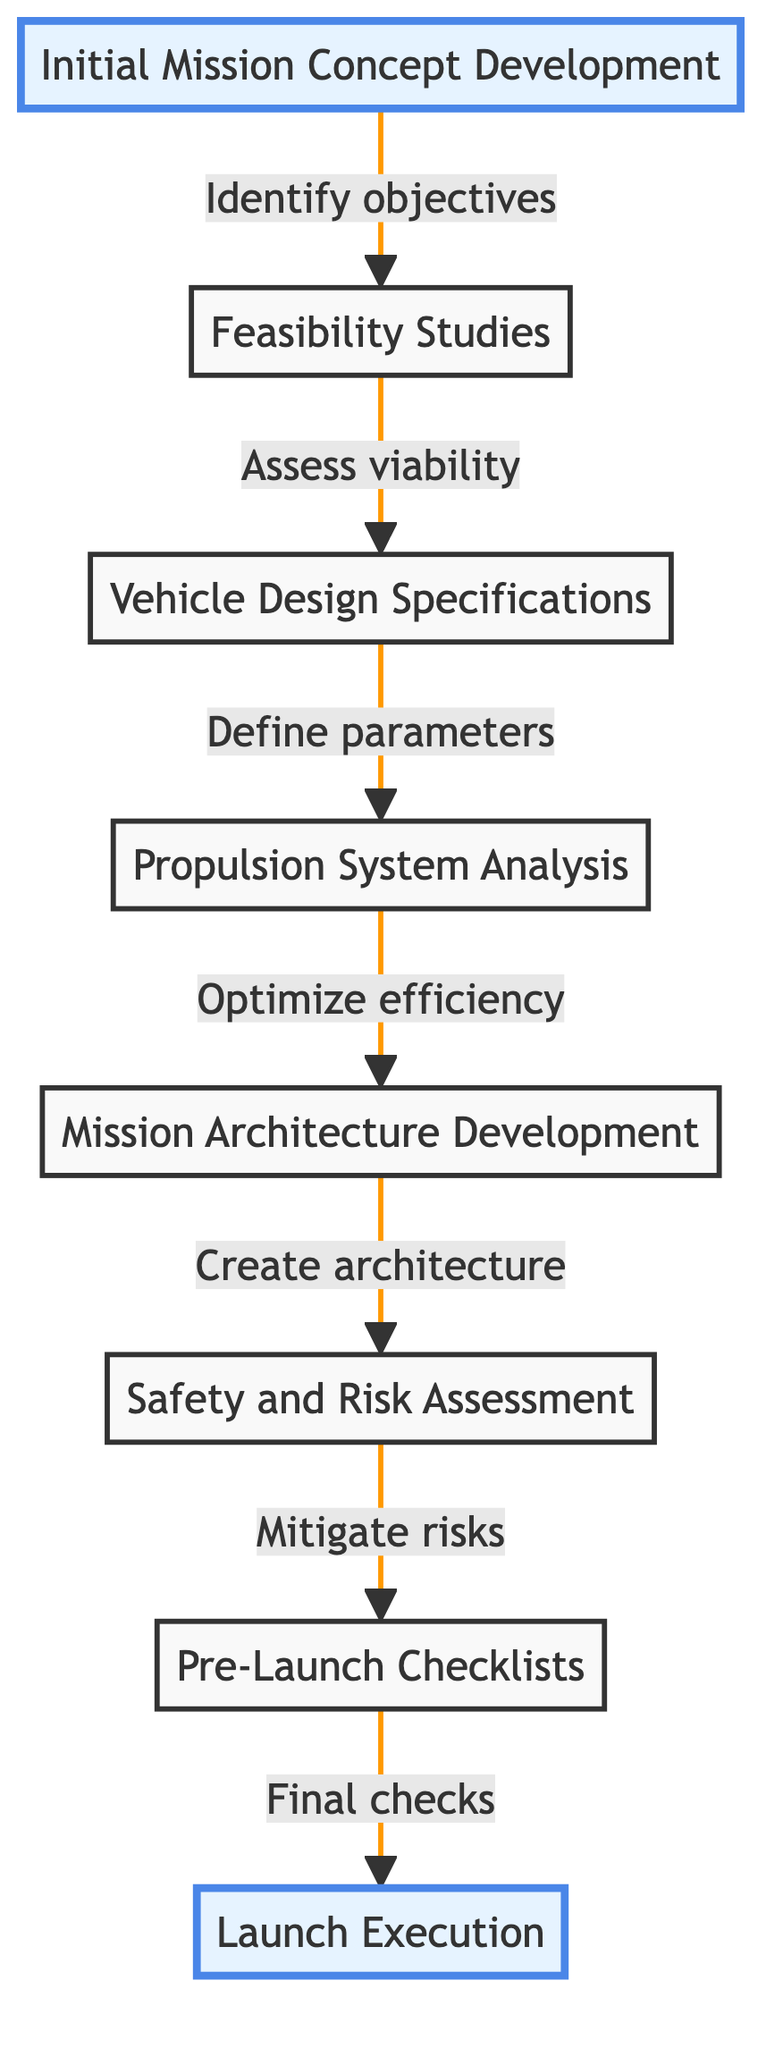What is the first step in the mission planning workflow? The first step shown in the diagram is "Initial Mission Concept Development," which identifies the mission objectives and payload requirements.
Answer: Initial Mission Concept Development How many steps are there in total in the flowchart? The diagram lists eight distinct steps that make up the mission planning workflow, from initial concept to launch execution.
Answer: 8 Which step directly follows the "Vehicle Design Specifications" step? According to the flowchart, the "Propulsion System Analysis" step directly follows "Vehicle Design Specifications," indicating an evaluation of propulsion options.
Answer: Propulsion System Analysis What is the relationship between "Safety and Risk Assessment" and "Pre-Launch Checklists"? "Safety and Risk Assessment" leads directly to "Pre-Launch Checklists," suggesting that assessing risks is a precursor to final systems checks before launch.
Answer: Pre-Launch Checklists Identify the step focused on optimizing fuel efficiency. The step dedicated to optimizing fuel efficiency is "Propulsion System Analysis," where various propulsion options are evaluated.
Answer: Propulsion System Analysis What actions are included in the "Launch Execution" phase? The "Launch Execution" phase involves carrying out the launch sequence and monitoring vehicle performance, marking the transition from preparation to action.
Answer: Launch Execution Which step requires both identifying hazards and mitigating risks? The "Safety and Risk Assessment" step involves both identifying potential hazards and implementing measures to mitigate those risks before moving forward to final checks.
Answer: Safety and Risk Assessment What is created during the "Mission Architecture Development"? This step focuses on creating a comprehensive mission architecture, which encompasses all aspects such as launch, orbit, and recovery systems.
Answer: Mission architecture What node emphasizes the importance of final checks before launch? The node "Pre-Launch Checklists" highlights the significance of completing final systems checks and preparations ahead of the actual launch.
Answer: Pre-Launch Checklists 